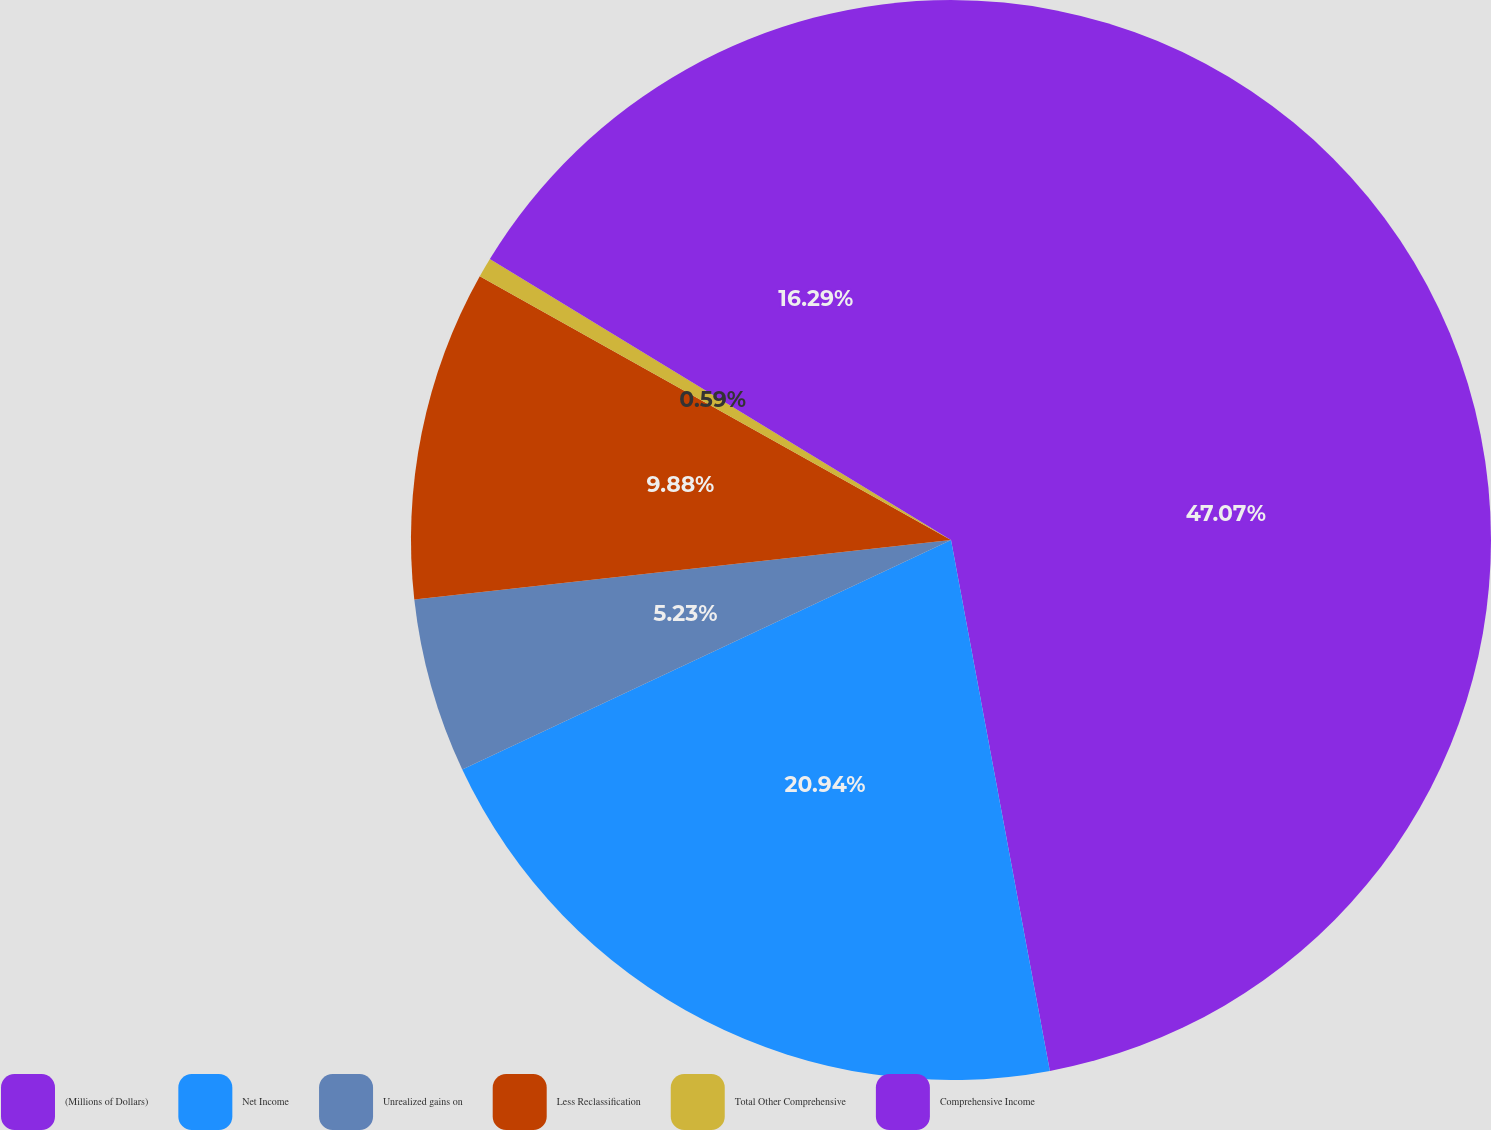Convert chart. <chart><loc_0><loc_0><loc_500><loc_500><pie_chart><fcel>(Millions of Dollars)<fcel>Net Income<fcel>Unrealized gains on<fcel>Less Reclassification<fcel>Total Other Comprehensive<fcel>Comprehensive Income<nl><fcel>47.07%<fcel>20.94%<fcel>5.23%<fcel>9.88%<fcel>0.59%<fcel>16.29%<nl></chart> 